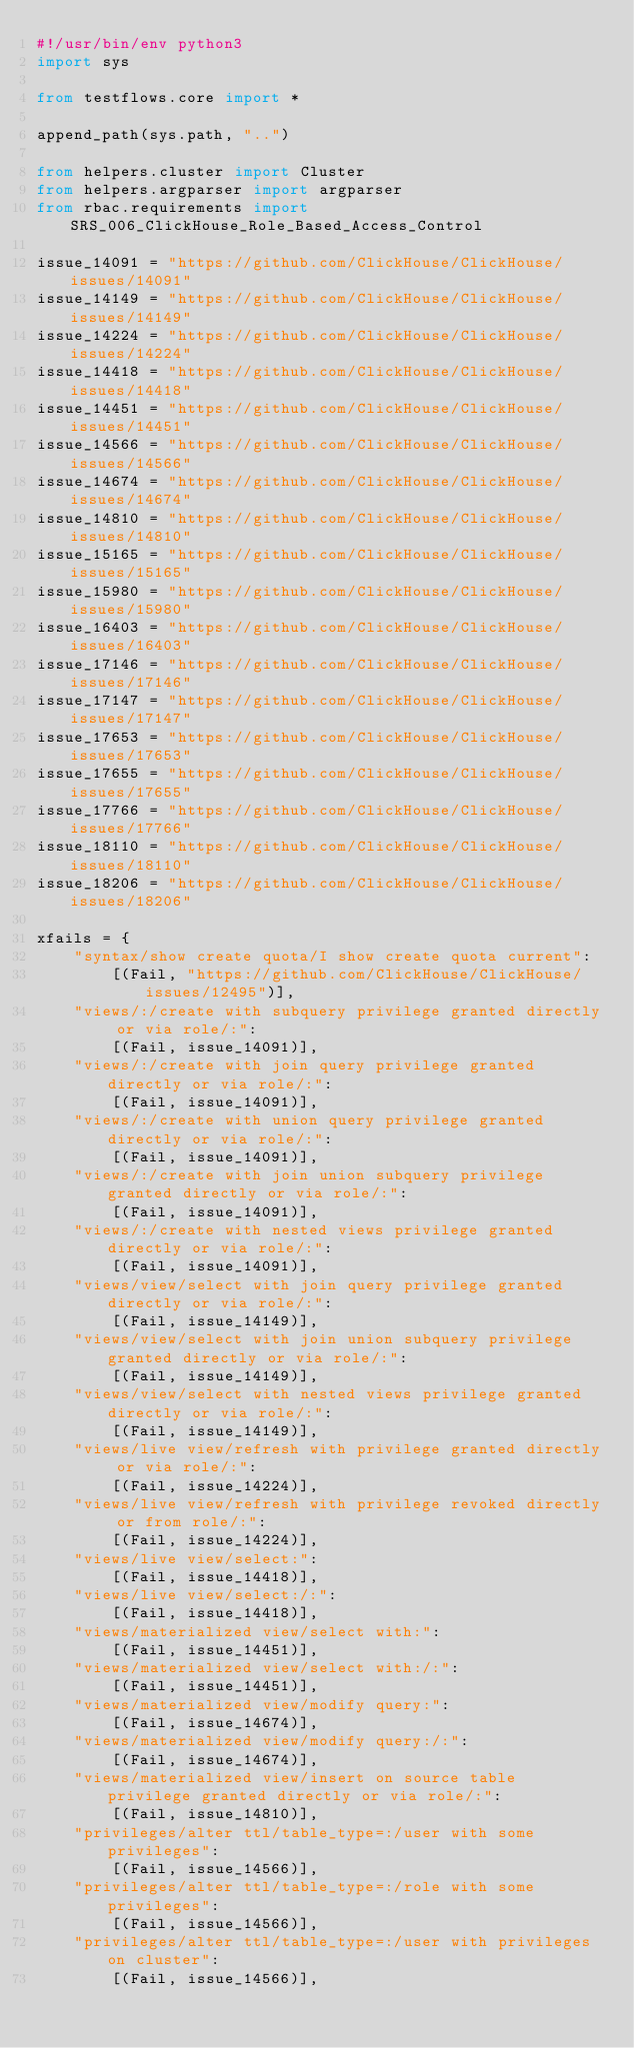<code> <loc_0><loc_0><loc_500><loc_500><_Python_>#!/usr/bin/env python3
import sys

from testflows.core import *

append_path(sys.path, "..")

from helpers.cluster import Cluster
from helpers.argparser import argparser
from rbac.requirements import SRS_006_ClickHouse_Role_Based_Access_Control

issue_14091 = "https://github.com/ClickHouse/ClickHouse/issues/14091"
issue_14149 = "https://github.com/ClickHouse/ClickHouse/issues/14149"
issue_14224 = "https://github.com/ClickHouse/ClickHouse/issues/14224"
issue_14418 = "https://github.com/ClickHouse/ClickHouse/issues/14418"
issue_14451 = "https://github.com/ClickHouse/ClickHouse/issues/14451"
issue_14566 = "https://github.com/ClickHouse/ClickHouse/issues/14566"
issue_14674 = "https://github.com/ClickHouse/ClickHouse/issues/14674"
issue_14810 = "https://github.com/ClickHouse/ClickHouse/issues/14810"
issue_15165 = "https://github.com/ClickHouse/ClickHouse/issues/15165"
issue_15980 = "https://github.com/ClickHouse/ClickHouse/issues/15980"
issue_16403 = "https://github.com/ClickHouse/ClickHouse/issues/16403"
issue_17146 = "https://github.com/ClickHouse/ClickHouse/issues/17146"
issue_17147 = "https://github.com/ClickHouse/ClickHouse/issues/17147"
issue_17653 = "https://github.com/ClickHouse/ClickHouse/issues/17653"
issue_17655 = "https://github.com/ClickHouse/ClickHouse/issues/17655"
issue_17766 = "https://github.com/ClickHouse/ClickHouse/issues/17766"
issue_18110 = "https://github.com/ClickHouse/ClickHouse/issues/18110"
issue_18206 = "https://github.com/ClickHouse/ClickHouse/issues/18206"

xfails = {
    "syntax/show create quota/I show create quota current":
        [(Fail, "https://github.com/ClickHouse/ClickHouse/issues/12495")],
    "views/:/create with subquery privilege granted directly or via role/:":
        [(Fail, issue_14091)],
    "views/:/create with join query privilege granted directly or via role/:":
        [(Fail, issue_14091)],
    "views/:/create with union query privilege granted directly or via role/:":
        [(Fail, issue_14091)],
    "views/:/create with join union subquery privilege granted directly or via role/:":
        [(Fail, issue_14091)],
    "views/:/create with nested views privilege granted directly or via role/:":
        [(Fail, issue_14091)],
    "views/view/select with join query privilege granted directly or via role/:":
        [(Fail, issue_14149)],
    "views/view/select with join union subquery privilege granted directly or via role/:":
        [(Fail, issue_14149)],
    "views/view/select with nested views privilege granted directly or via role/:":
        [(Fail, issue_14149)],
    "views/live view/refresh with privilege granted directly or via role/:":
        [(Fail, issue_14224)],
    "views/live view/refresh with privilege revoked directly or from role/:":
        [(Fail, issue_14224)],
    "views/live view/select:":
        [(Fail, issue_14418)],
    "views/live view/select:/:":
        [(Fail, issue_14418)],
    "views/materialized view/select with:":
        [(Fail, issue_14451)],
    "views/materialized view/select with:/:":
        [(Fail, issue_14451)],
    "views/materialized view/modify query:":
        [(Fail, issue_14674)],
    "views/materialized view/modify query:/:":
        [(Fail, issue_14674)],
    "views/materialized view/insert on source table privilege granted directly or via role/:":
        [(Fail, issue_14810)],
    "privileges/alter ttl/table_type=:/user with some privileges":
        [(Fail, issue_14566)],
    "privileges/alter ttl/table_type=:/role with some privileges":
        [(Fail, issue_14566)],
    "privileges/alter ttl/table_type=:/user with privileges on cluster":
        [(Fail, issue_14566)],</code> 